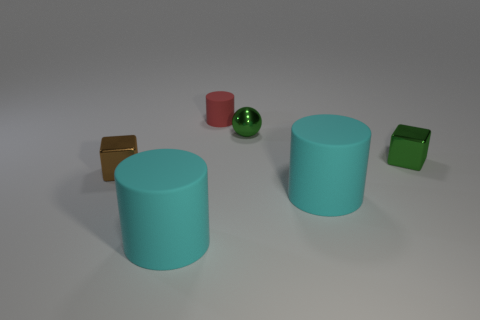Subtract all big cyan rubber cylinders. How many cylinders are left? 1 Add 1 small brown metal objects. How many objects exist? 7 Subtract all spheres. How many objects are left? 5 Subtract all red shiny cylinders. Subtract all red matte cylinders. How many objects are left? 5 Add 6 cylinders. How many cylinders are left? 9 Add 3 big blue things. How many big blue things exist? 3 Subtract 0 blue spheres. How many objects are left? 6 